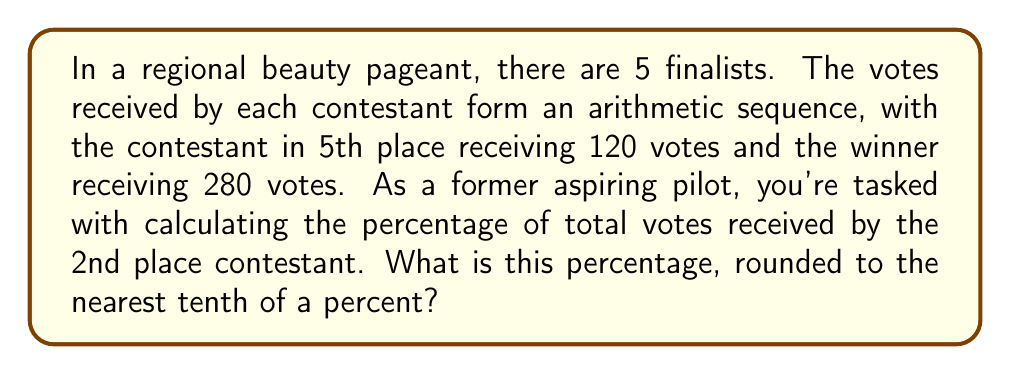Give your solution to this math problem. Let's approach this step-by-step:

1) In an arithmetic sequence, the difference between each term is constant. Let's call this common difference $d$.

2) We know the first term (5th place) is $a_1 = 120$ and the last term (1st place) is $a_5 = 280$.

3) We can use the arithmetic sequence formula:
   $a_n = a_1 + (n-1)d$
   $280 = 120 + (5-1)d$
   $280 = 120 + 4d$
   $160 = 4d$
   $d = 40$

4) Now we can calculate all the votes:
   5th place: 120
   4th place: 120 + 40 = 160
   3rd place: 160 + 40 = 200
   2nd place: 200 + 40 = 240
   1st place: 240 + 40 = 280

5) The total votes:
   $S = \frac{n(a_1 + a_n)}{2} = \frac{5(120 + 280)}{2} = 1000$

6) The 2nd place contestant received 240 votes.

7) To calculate the percentage:
   $\text{Percentage} = \frac{\text{Votes for 2nd place}}{\text{Total votes}} \times 100\%$
   $= \frac{240}{1000} \times 100\% = 24\%$
Answer: 24.0% 